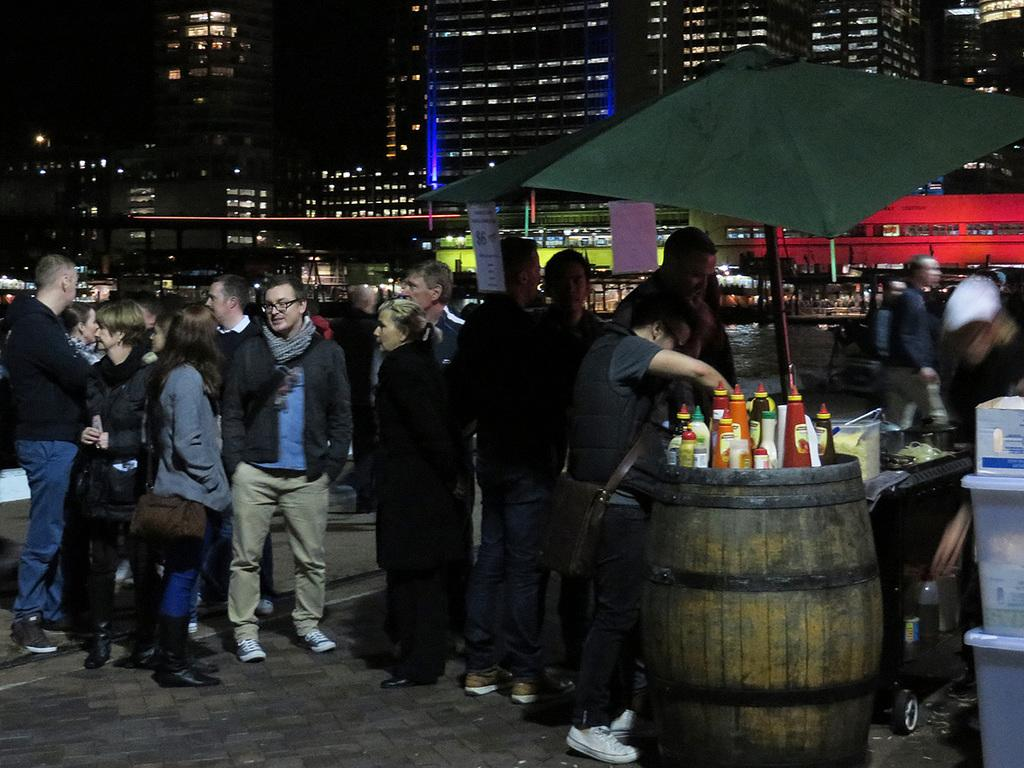What type of structures can be seen in the image? There are buildings in the image. What type of lighting is visible in the image? Electric lights are visible in the image. What natural element is present in the image? There is water in the image. What are the people in the image doing? There are persons standing on the floor in the image. What type of shade provider is present in the image? A parasol is present in the image. What type of food-related items are visible in the image? Condiments are on a barrel in the image, and containers are present in the image. What type of sofa can be seen in the image? There is no sofa present in the image. What color is the lipstick on the person's face in the image? There is no lipstick or person's face visible in the image. 